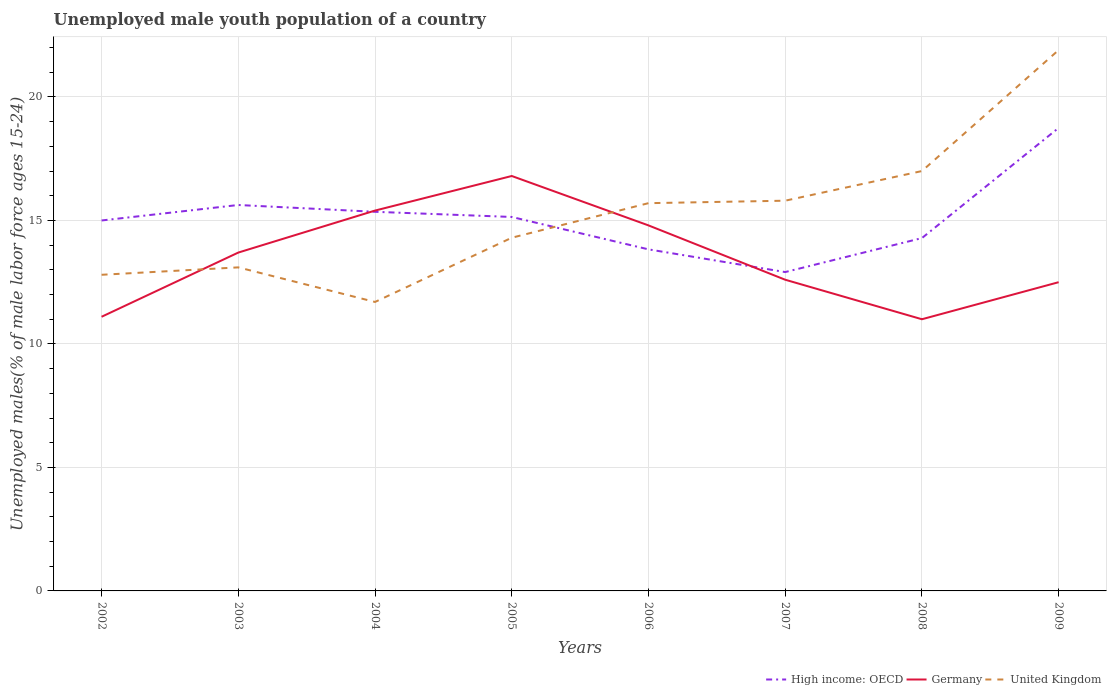Does the line corresponding to United Kingdom intersect with the line corresponding to Germany?
Keep it short and to the point. Yes. Across all years, what is the maximum percentage of unemployed male youth population in Germany?
Provide a succinct answer. 11. In which year was the percentage of unemployed male youth population in High income: OECD maximum?
Provide a short and direct response. 2007. What is the total percentage of unemployed male youth population in Germany in the graph?
Keep it short and to the point. 5.8. What is the difference between the highest and the second highest percentage of unemployed male youth population in Germany?
Ensure brevity in your answer.  5.8. Is the percentage of unemployed male youth population in Germany strictly greater than the percentage of unemployed male youth population in High income: OECD over the years?
Ensure brevity in your answer.  No. Are the values on the major ticks of Y-axis written in scientific E-notation?
Your answer should be compact. No. Does the graph contain any zero values?
Offer a very short reply. No. Where does the legend appear in the graph?
Provide a succinct answer. Bottom right. How many legend labels are there?
Provide a succinct answer. 3. What is the title of the graph?
Keep it short and to the point. Unemployed male youth population of a country. Does "Sweden" appear as one of the legend labels in the graph?
Offer a very short reply. No. What is the label or title of the Y-axis?
Give a very brief answer. Unemployed males(% of male labor force ages 15-24). What is the Unemployed males(% of male labor force ages 15-24) in High income: OECD in 2002?
Make the answer very short. 15. What is the Unemployed males(% of male labor force ages 15-24) of Germany in 2002?
Make the answer very short. 11.1. What is the Unemployed males(% of male labor force ages 15-24) in United Kingdom in 2002?
Your answer should be very brief. 12.8. What is the Unemployed males(% of male labor force ages 15-24) of High income: OECD in 2003?
Keep it short and to the point. 15.63. What is the Unemployed males(% of male labor force ages 15-24) of Germany in 2003?
Keep it short and to the point. 13.7. What is the Unemployed males(% of male labor force ages 15-24) of United Kingdom in 2003?
Provide a short and direct response. 13.1. What is the Unemployed males(% of male labor force ages 15-24) in High income: OECD in 2004?
Offer a very short reply. 15.35. What is the Unemployed males(% of male labor force ages 15-24) in Germany in 2004?
Your response must be concise. 15.4. What is the Unemployed males(% of male labor force ages 15-24) in United Kingdom in 2004?
Keep it short and to the point. 11.7. What is the Unemployed males(% of male labor force ages 15-24) in High income: OECD in 2005?
Your answer should be compact. 15.14. What is the Unemployed males(% of male labor force ages 15-24) of Germany in 2005?
Your answer should be very brief. 16.8. What is the Unemployed males(% of male labor force ages 15-24) of United Kingdom in 2005?
Your response must be concise. 14.3. What is the Unemployed males(% of male labor force ages 15-24) in High income: OECD in 2006?
Offer a terse response. 13.83. What is the Unemployed males(% of male labor force ages 15-24) of Germany in 2006?
Offer a terse response. 14.8. What is the Unemployed males(% of male labor force ages 15-24) in United Kingdom in 2006?
Provide a succinct answer. 15.7. What is the Unemployed males(% of male labor force ages 15-24) of High income: OECD in 2007?
Offer a terse response. 12.91. What is the Unemployed males(% of male labor force ages 15-24) of Germany in 2007?
Your answer should be very brief. 12.6. What is the Unemployed males(% of male labor force ages 15-24) of United Kingdom in 2007?
Offer a terse response. 15.8. What is the Unemployed males(% of male labor force ages 15-24) of High income: OECD in 2008?
Offer a terse response. 14.29. What is the Unemployed males(% of male labor force ages 15-24) of Germany in 2008?
Your response must be concise. 11. What is the Unemployed males(% of male labor force ages 15-24) of United Kingdom in 2008?
Provide a succinct answer. 17. What is the Unemployed males(% of male labor force ages 15-24) in High income: OECD in 2009?
Your answer should be very brief. 18.75. What is the Unemployed males(% of male labor force ages 15-24) of United Kingdom in 2009?
Make the answer very short. 21.9. Across all years, what is the maximum Unemployed males(% of male labor force ages 15-24) in High income: OECD?
Give a very brief answer. 18.75. Across all years, what is the maximum Unemployed males(% of male labor force ages 15-24) of Germany?
Provide a succinct answer. 16.8. Across all years, what is the maximum Unemployed males(% of male labor force ages 15-24) in United Kingdom?
Your response must be concise. 21.9. Across all years, what is the minimum Unemployed males(% of male labor force ages 15-24) in High income: OECD?
Provide a short and direct response. 12.91. Across all years, what is the minimum Unemployed males(% of male labor force ages 15-24) in United Kingdom?
Your answer should be very brief. 11.7. What is the total Unemployed males(% of male labor force ages 15-24) of High income: OECD in the graph?
Ensure brevity in your answer.  120.89. What is the total Unemployed males(% of male labor force ages 15-24) in Germany in the graph?
Offer a very short reply. 107.9. What is the total Unemployed males(% of male labor force ages 15-24) of United Kingdom in the graph?
Offer a terse response. 122.3. What is the difference between the Unemployed males(% of male labor force ages 15-24) of High income: OECD in 2002 and that in 2003?
Your answer should be compact. -0.63. What is the difference between the Unemployed males(% of male labor force ages 15-24) in Germany in 2002 and that in 2003?
Give a very brief answer. -2.6. What is the difference between the Unemployed males(% of male labor force ages 15-24) of United Kingdom in 2002 and that in 2003?
Keep it short and to the point. -0.3. What is the difference between the Unemployed males(% of male labor force ages 15-24) in High income: OECD in 2002 and that in 2004?
Offer a terse response. -0.35. What is the difference between the Unemployed males(% of male labor force ages 15-24) of United Kingdom in 2002 and that in 2004?
Ensure brevity in your answer.  1.1. What is the difference between the Unemployed males(% of male labor force ages 15-24) of High income: OECD in 2002 and that in 2005?
Your response must be concise. -0.14. What is the difference between the Unemployed males(% of male labor force ages 15-24) in Germany in 2002 and that in 2005?
Give a very brief answer. -5.7. What is the difference between the Unemployed males(% of male labor force ages 15-24) in United Kingdom in 2002 and that in 2005?
Ensure brevity in your answer.  -1.5. What is the difference between the Unemployed males(% of male labor force ages 15-24) in High income: OECD in 2002 and that in 2006?
Your answer should be very brief. 1.17. What is the difference between the Unemployed males(% of male labor force ages 15-24) in Germany in 2002 and that in 2006?
Make the answer very short. -3.7. What is the difference between the Unemployed males(% of male labor force ages 15-24) in United Kingdom in 2002 and that in 2006?
Provide a succinct answer. -2.9. What is the difference between the Unemployed males(% of male labor force ages 15-24) of High income: OECD in 2002 and that in 2007?
Ensure brevity in your answer.  2.09. What is the difference between the Unemployed males(% of male labor force ages 15-24) in United Kingdom in 2002 and that in 2007?
Make the answer very short. -3. What is the difference between the Unemployed males(% of male labor force ages 15-24) in High income: OECD in 2002 and that in 2008?
Offer a very short reply. 0.71. What is the difference between the Unemployed males(% of male labor force ages 15-24) in Germany in 2002 and that in 2008?
Make the answer very short. 0.1. What is the difference between the Unemployed males(% of male labor force ages 15-24) of United Kingdom in 2002 and that in 2008?
Make the answer very short. -4.2. What is the difference between the Unemployed males(% of male labor force ages 15-24) of High income: OECD in 2002 and that in 2009?
Your answer should be very brief. -3.75. What is the difference between the Unemployed males(% of male labor force ages 15-24) in High income: OECD in 2003 and that in 2004?
Ensure brevity in your answer.  0.28. What is the difference between the Unemployed males(% of male labor force ages 15-24) in High income: OECD in 2003 and that in 2005?
Provide a short and direct response. 0.48. What is the difference between the Unemployed males(% of male labor force ages 15-24) of Germany in 2003 and that in 2005?
Your answer should be very brief. -3.1. What is the difference between the Unemployed males(% of male labor force ages 15-24) in High income: OECD in 2003 and that in 2006?
Provide a short and direct response. 1.8. What is the difference between the Unemployed males(% of male labor force ages 15-24) of United Kingdom in 2003 and that in 2006?
Make the answer very short. -2.6. What is the difference between the Unemployed males(% of male labor force ages 15-24) in High income: OECD in 2003 and that in 2007?
Offer a very short reply. 2.72. What is the difference between the Unemployed males(% of male labor force ages 15-24) in High income: OECD in 2003 and that in 2008?
Your answer should be compact. 1.34. What is the difference between the Unemployed males(% of male labor force ages 15-24) in Germany in 2003 and that in 2008?
Give a very brief answer. 2.7. What is the difference between the Unemployed males(% of male labor force ages 15-24) in High income: OECD in 2003 and that in 2009?
Your response must be concise. -3.12. What is the difference between the Unemployed males(% of male labor force ages 15-24) of Germany in 2003 and that in 2009?
Your response must be concise. 1.2. What is the difference between the Unemployed males(% of male labor force ages 15-24) of United Kingdom in 2003 and that in 2009?
Ensure brevity in your answer.  -8.8. What is the difference between the Unemployed males(% of male labor force ages 15-24) in High income: OECD in 2004 and that in 2005?
Keep it short and to the point. 0.21. What is the difference between the Unemployed males(% of male labor force ages 15-24) of United Kingdom in 2004 and that in 2005?
Make the answer very short. -2.6. What is the difference between the Unemployed males(% of male labor force ages 15-24) of High income: OECD in 2004 and that in 2006?
Your answer should be compact. 1.52. What is the difference between the Unemployed males(% of male labor force ages 15-24) in Germany in 2004 and that in 2006?
Provide a short and direct response. 0.6. What is the difference between the Unemployed males(% of male labor force ages 15-24) of United Kingdom in 2004 and that in 2006?
Give a very brief answer. -4. What is the difference between the Unemployed males(% of male labor force ages 15-24) of High income: OECD in 2004 and that in 2007?
Your response must be concise. 2.44. What is the difference between the Unemployed males(% of male labor force ages 15-24) in Germany in 2004 and that in 2007?
Offer a very short reply. 2.8. What is the difference between the Unemployed males(% of male labor force ages 15-24) of High income: OECD in 2004 and that in 2008?
Ensure brevity in your answer.  1.06. What is the difference between the Unemployed males(% of male labor force ages 15-24) in Germany in 2004 and that in 2008?
Give a very brief answer. 4.4. What is the difference between the Unemployed males(% of male labor force ages 15-24) in United Kingdom in 2004 and that in 2008?
Give a very brief answer. -5.3. What is the difference between the Unemployed males(% of male labor force ages 15-24) in High income: OECD in 2004 and that in 2009?
Offer a very short reply. -3.4. What is the difference between the Unemployed males(% of male labor force ages 15-24) in United Kingdom in 2004 and that in 2009?
Provide a succinct answer. -10.2. What is the difference between the Unemployed males(% of male labor force ages 15-24) of High income: OECD in 2005 and that in 2006?
Offer a terse response. 1.31. What is the difference between the Unemployed males(% of male labor force ages 15-24) in United Kingdom in 2005 and that in 2006?
Your answer should be compact. -1.4. What is the difference between the Unemployed males(% of male labor force ages 15-24) in High income: OECD in 2005 and that in 2007?
Offer a terse response. 2.23. What is the difference between the Unemployed males(% of male labor force ages 15-24) of United Kingdom in 2005 and that in 2007?
Your answer should be compact. -1.5. What is the difference between the Unemployed males(% of male labor force ages 15-24) in High income: OECD in 2005 and that in 2008?
Ensure brevity in your answer.  0.86. What is the difference between the Unemployed males(% of male labor force ages 15-24) in United Kingdom in 2005 and that in 2008?
Give a very brief answer. -2.7. What is the difference between the Unemployed males(% of male labor force ages 15-24) of High income: OECD in 2005 and that in 2009?
Ensure brevity in your answer.  -3.61. What is the difference between the Unemployed males(% of male labor force ages 15-24) in Germany in 2005 and that in 2009?
Offer a very short reply. 4.3. What is the difference between the Unemployed males(% of male labor force ages 15-24) in United Kingdom in 2005 and that in 2009?
Ensure brevity in your answer.  -7.6. What is the difference between the Unemployed males(% of male labor force ages 15-24) of High income: OECD in 2006 and that in 2007?
Offer a very short reply. 0.92. What is the difference between the Unemployed males(% of male labor force ages 15-24) of Germany in 2006 and that in 2007?
Your answer should be very brief. 2.2. What is the difference between the Unemployed males(% of male labor force ages 15-24) in United Kingdom in 2006 and that in 2007?
Your answer should be very brief. -0.1. What is the difference between the Unemployed males(% of male labor force ages 15-24) in High income: OECD in 2006 and that in 2008?
Your response must be concise. -0.46. What is the difference between the Unemployed males(% of male labor force ages 15-24) of Germany in 2006 and that in 2008?
Your answer should be very brief. 3.8. What is the difference between the Unemployed males(% of male labor force ages 15-24) of United Kingdom in 2006 and that in 2008?
Offer a very short reply. -1.3. What is the difference between the Unemployed males(% of male labor force ages 15-24) of High income: OECD in 2006 and that in 2009?
Give a very brief answer. -4.92. What is the difference between the Unemployed males(% of male labor force ages 15-24) in High income: OECD in 2007 and that in 2008?
Ensure brevity in your answer.  -1.38. What is the difference between the Unemployed males(% of male labor force ages 15-24) of High income: OECD in 2007 and that in 2009?
Provide a short and direct response. -5.84. What is the difference between the Unemployed males(% of male labor force ages 15-24) of Germany in 2007 and that in 2009?
Keep it short and to the point. 0.1. What is the difference between the Unemployed males(% of male labor force ages 15-24) of High income: OECD in 2008 and that in 2009?
Your response must be concise. -4.46. What is the difference between the Unemployed males(% of male labor force ages 15-24) in United Kingdom in 2008 and that in 2009?
Keep it short and to the point. -4.9. What is the difference between the Unemployed males(% of male labor force ages 15-24) of High income: OECD in 2002 and the Unemployed males(% of male labor force ages 15-24) of Germany in 2003?
Provide a short and direct response. 1.3. What is the difference between the Unemployed males(% of male labor force ages 15-24) in High income: OECD in 2002 and the Unemployed males(% of male labor force ages 15-24) in United Kingdom in 2003?
Ensure brevity in your answer.  1.9. What is the difference between the Unemployed males(% of male labor force ages 15-24) of Germany in 2002 and the Unemployed males(% of male labor force ages 15-24) of United Kingdom in 2003?
Keep it short and to the point. -2. What is the difference between the Unemployed males(% of male labor force ages 15-24) of High income: OECD in 2002 and the Unemployed males(% of male labor force ages 15-24) of Germany in 2004?
Ensure brevity in your answer.  -0.4. What is the difference between the Unemployed males(% of male labor force ages 15-24) in High income: OECD in 2002 and the Unemployed males(% of male labor force ages 15-24) in United Kingdom in 2004?
Provide a short and direct response. 3.3. What is the difference between the Unemployed males(% of male labor force ages 15-24) in High income: OECD in 2002 and the Unemployed males(% of male labor force ages 15-24) in Germany in 2005?
Ensure brevity in your answer.  -1.8. What is the difference between the Unemployed males(% of male labor force ages 15-24) in High income: OECD in 2002 and the Unemployed males(% of male labor force ages 15-24) in United Kingdom in 2005?
Provide a short and direct response. 0.7. What is the difference between the Unemployed males(% of male labor force ages 15-24) in High income: OECD in 2002 and the Unemployed males(% of male labor force ages 15-24) in Germany in 2006?
Offer a terse response. 0.2. What is the difference between the Unemployed males(% of male labor force ages 15-24) of High income: OECD in 2002 and the Unemployed males(% of male labor force ages 15-24) of United Kingdom in 2006?
Provide a succinct answer. -0.7. What is the difference between the Unemployed males(% of male labor force ages 15-24) in High income: OECD in 2002 and the Unemployed males(% of male labor force ages 15-24) in Germany in 2007?
Your answer should be very brief. 2.4. What is the difference between the Unemployed males(% of male labor force ages 15-24) in High income: OECD in 2002 and the Unemployed males(% of male labor force ages 15-24) in United Kingdom in 2007?
Ensure brevity in your answer.  -0.8. What is the difference between the Unemployed males(% of male labor force ages 15-24) in Germany in 2002 and the Unemployed males(% of male labor force ages 15-24) in United Kingdom in 2007?
Provide a short and direct response. -4.7. What is the difference between the Unemployed males(% of male labor force ages 15-24) of High income: OECD in 2002 and the Unemployed males(% of male labor force ages 15-24) of Germany in 2008?
Make the answer very short. 4. What is the difference between the Unemployed males(% of male labor force ages 15-24) in High income: OECD in 2002 and the Unemployed males(% of male labor force ages 15-24) in United Kingdom in 2008?
Offer a terse response. -2. What is the difference between the Unemployed males(% of male labor force ages 15-24) in Germany in 2002 and the Unemployed males(% of male labor force ages 15-24) in United Kingdom in 2008?
Keep it short and to the point. -5.9. What is the difference between the Unemployed males(% of male labor force ages 15-24) in High income: OECD in 2002 and the Unemployed males(% of male labor force ages 15-24) in Germany in 2009?
Offer a terse response. 2.5. What is the difference between the Unemployed males(% of male labor force ages 15-24) in High income: OECD in 2002 and the Unemployed males(% of male labor force ages 15-24) in United Kingdom in 2009?
Your response must be concise. -6.9. What is the difference between the Unemployed males(% of male labor force ages 15-24) in Germany in 2002 and the Unemployed males(% of male labor force ages 15-24) in United Kingdom in 2009?
Your answer should be compact. -10.8. What is the difference between the Unemployed males(% of male labor force ages 15-24) in High income: OECD in 2003 and the Unemployed males(% of male labor force ages 15-24) in Germany in 2004?
Provide a short and direct response. 0.23. What is the difference between the Unemployed males(% of male labor force ages 15-24) of High income: OECD in 2003 and the Unemployed males(% of male labor force ages 15-24) of United Kingdom in 2004?
Your answer should be compact. 3.93. What is the difference between the Unemployed males(% of male labor force ages 15-24) in High income: OECD in 2003 and the Unemployed males(% of male labor force ages 15-24) in Germany in 2005?
Give a very brief answer. -1.17. What is the difference between the Unemployed males(% of male labor force ages 15-24) of High income: OECD in 2003 and the Unemployed males(% of male labor force ages 15-24) of United Kingdom in 2005?
Offer a very short reply. 1.33. What is the difference between the Unemployed males(% of male labor force ages 15-24) of High income: OECD in 2003 and the Unemployed males(% of male labor force ages 15-24) of Germany in 2006?
Provide a short and direct response. 0.83. What is the difference between the Unemployed males(% of male labor force ages 15-24) of High income: OECD in 2003 and the Unemployed males(% of male labor force ages 15-24) of United Kingdom in 2006?
Make the answer very short. -0.07. What is the difference between the Unemployed males(% of male labor force ages 15-24) in Germany in 2003 and the Unemployed males(% of male labor force ages 15-24) in United Kingdom in 2006?
Provide a short and direct response. -2. What is the difference between the Unemployed males(% of male labor force ages 15-24) of High income: OECD in 2003 and the Unemployed males(% of male labor force ages 15-24) of Germany in 2007?
Offer a terse response. 3.03. What is the difference between the Unemployed males(% of male labor force ages 15-24) of High income: OECD in 2003 and the Unemployed males(% of male labor force ages 15-24) of United Kingdom in 2007?
Your answer should be compact. -0.17. What is the difference between the Unemployed males(% of male labor force ages 15-24) in High income: OECD in 2003 and the Unemployed males(% of male labor force ages 15-24) in Germany in 2008?
Provide a short and direct response. 4.63. What is the difference between the Unemployed males(% of male labor force ages 15-24) of High income: OECD in 2003 and the Unemployed males(% of male labor force ages 15-24) of United Kingdom in 2008?
Your answer should be compact. -1.37. What is the difference between the Unemployed males(% of male labor force ages 15-24) in High income: OECD in 2003 and the Unemployed males(% of male labor force ages 15-24) in Germany in 2009?
Provide a short and direct response. 3.13. What is the difference between the Unemployed males(% of male labor force ages 15-24) in High income: OECD in 2003 and the Unemployed males(% of male labor force ages 15-24) in United Kingdom in 2009?
Provide a short and direct response. -6.27. What is the difference between the Unemployed males(% of male labor force ages 15-24) in Germany in 2003 and the Unemployed males(% of male labor force ages 15-24) in United Kingdom in 2009?
Provide a short and direct response. -8.2. What is the difference between the Unemployed males(% of male labor force ages 15-24) in High income: OECD in 2004 and the Unemployed males(% of male labor force ages 15-24) in Germany in 2005?
Your answer should be very brief. -1.45. What is the difference between the Unemployed males(% of male labor force ages 15-24) in High income: OECD in 2004 and the Unemployed males(% of male labor force ages 15-24) in United Kingdom in 2005?
Give a very brief answer. 1.05. What is the difference between the Unemployed males(% of male labor force ages 15-24) in High income: OECD in 2004 and the Unemployed males(% of male labor force ages 15-24) in Germany in 2006?
Ensure brevity in your answer.  0.55. What is the difference between the Unemployed males(% of male labor force ages 15-24) in High income: OECD in 2004 and the Unemployed males(% of male labor force ages 15-24) in United Kingdom in 2006?
Your answer should be very brief. -0.35. What is the difference between the Unemployed males(% of male labor force ages 15-24) of High income: OECD in 2004 and the Unemployed males(% of male labor force ages 15-24) of Germany in 2007?
Provide a succinct answer. 2.75. What is the difference between the Unemployed males(% of male labor force ages 15-24) in High income: OECD in 2004 and the Unemployed males(% of male labor force ages 15-24) in United Kingdom in 2007?
Ensure brevity in your answer.  -0.45. What is the difference between the Unemployed males(% of male labor force ages 15-24) in High income: OECD in 2004 and the Unemployed males(% of male labor force ages 15-24) in Germany in 2008?
Offer a terse response. 4.35. What is the difference between the Unemployed males(% of male labor force ages 15-24) of High income: OECD in 2004 and the Unemployed males(% of male labor force ages 15-24) of United Kingdom in 2008?
Offer a terse response. -1.65. What is the difference between the Unemployed males(% of male labor force ages 15-24) in High income: OECD in 2004 and the Unemployed males(% of male labor force ages 15-24) in Germany in 2009?
Offer a very short reply. 2.85. What is the difference between the Unemployed males(% of male labor force ages 15-24) of High income: OECD in 2004 and the Unemployed males(% of male labor force ages 15-24) of United Kingdom in 2009?
Your answer should be compact. -6.55. What is the difference between the Unemployed males(% of male labor force ages 15-24) of Germany in 2004 and the Unemployed males(% of male labor force ages 15-24) of United Kingdom in 2009?
Offer a very short reply. -6.5. What is the difference between the Unemployed males(% of male labor force ages 15-24) in High income: OECD in 2005 and the Unemployed males(% of male labor force ages 15-24) in Germany in 2006?
Offer a terse response. 0.34. What is the difference between the Unemployed males(% of male labor force ages 15-24) of High income: OECD in 2005 and the Unemployed males(% of male labor force ages 15-24) of United Kingdom in 2006?
Your response must be concise. -0.56. What is the difference between the Unemployed males(% of male labor force ages 15-24) of Germany in 2005 and the Unemployed males(% of male labor force ages 15-24) of United Kingdom in 2006?
Provide a succinct answer. 1.1. What is the difference between the Unemployed males(% of male labor force ages 15-24) of High income: OECD in 2005 and the Unemployed males(% of male labor force ages 15-24) of Germany in 2007?
Offer a terse response. 2.54. What is the difference between the Unemployed males(% of male labor force ages 15-24) of High income: OECD in 2005 and the Unemployed males(% of male labor force ages 15-24) of United Kingdom in 2007?
Your answer should be compact. -0.66. What is the difference between the Unemployed males(% of male labor force ages 15-24) of High income: OECD in 2005 and the Unemployed males(% of male labor force ages 15-24) of Germany in 2008?
Offer a very short reply. 4.14. What is the difference between the Unemployed males(% of male labor force ages 15-24) of High income: OECD in 2005 and the Unemployed males(% of male labor force ages 15-24) of United Kingdom in 2008?
Ensure brevity in your answer.  -1.86. What is the difference between the Unemployed males(% of male labor force ages 15-24) in Germany in 2005 and the Unemployed males(% of male labor force ages 15-24) in United Kingdom in 2008?
Offer a very short reply. -0.2. What is the difference between the Unemployed males(% of male labor force ages 15-24) in High income: OECD in 2005 and the Unemployed males(% of male labor force ages 15-24) in Germany in 2009?
Offer a very short reply. 2.64. What is the difference between the Unemployed males(% of male labor force ages 15-24) of High income: OECD in 2005 and the Unemployed males(% of male labor force ages 15-24) of United Kingdom in 2009?
Offer a very short reply. -6.76. What is the difference between the Unemployed males(% of male labor force ages 15-24) in High income: OECD in 2006 and the Unemployed males(% of male labor force ages 15-24) in Germany in 2007?
Your answer should be compact. 1.23. What is the difference between the Unemployed males(% of male labor force ages 15-24) of High income: OECD in 2006 and the Unemployed males(% of male labor force ages 15-24) of United Kingdom in 2007?
Make the answer very short. -1.97. What is the difference between the Unemployed males(% of male labor force ages 15-24) in Germany in 2006 and the Unemployed males(% of male labor force ages 15-24) in United Kingdom in 2007?
Make the answer very short. -1. What is the difference between the Unemployed males(% of male labor force ages 15-24) of High income: OECD in 2006 and the Unemployed males(% of male labor force ages 15-24) of Germany in 2008?
Ensure brevity in your answer.  2.83. What is the difference between the Unemployed males(% of male labor force ages 15-24) in High income: OECD in 2006 and the Unemployed males(% of male labor force ages 15-24) in United Kingdom in 2008?
Your answer should be very brief. -3.17. What is the difference between the Unemployed males(% of male labor force ages 15-24) of Germany in 2006 and the Unemployed males(% of male labor force ages 15-24) of United Kingdom in 2008?
Provide a short and direct response. -2.2. What is the difference between the Unemployed males(% of male labor force ages 15-24) in High income: OECD in 2006 and the Unemployed males(% of male labor force ages 15-24) in Germany in 2009?
Make the answer very short. 1.33. What is the difference between the Unemployed males(% of male labor force ages 15-24) in High income: OECD in 2006 and the Unemployed males(% of male labor force ages 15-24) in United Kingdom in 2009?
Offer a very short reply. -8.07. What is the difference between the Unemployed males(% of male labor force ages 15-24) of High income: OECD in 2007 and the Unemployed males(% of male labor force ages 15-24) of Germany in 2008?
Give a very brief answer. 1.91. What is the difference between the Unemployed males(% of male labor force ages 15-24) in High income: OECD in 2007 and the Unemployed males(% of male labor force ages 15-24) in United Kingdom in 2008?
Offer a very short reply. -4.09. What is the difference between the Unemployed males(% of male labor force ages 15-24) of Germany in 2007 and the Unemployed males(% of male labor force ages 15-24) of United Kingdom in 2008?
Make the answer very short. -4.4. What is the difference between the Unemployed males(% of male labor force ages 15-24) in High income: OECD in 2007 and the Unemployed males(% of male labor force ages 15-24) in Germany in 2009?
Your answer should be compact. 0.41. What is the difference between the Unemployed males(% of male labor force ages 15-24) of High income: OECD in 2007 and the Unemployed males(% of male labor force ages 15-24) of United Kingdom in 2009?
Offer a terse response. -8.99. What is the difference between the Unemployed males(% of male labor force ages 15-24) of Germany in 2007 and the Unemployed males(% of male labor force ages 15-24) of United Kingdom in 2009?
Make the answer very short. -9.3. What is the difference between the Unemployed males(% of male labor force ages 15-24) of High income: OECD in 2008 and the Unemployed males(% of male labor force ages 15-24) of Germany in 2009?
Provide a succinct answer. 1.79. What is the difference between the Unemployed males(% of male labor force ages 15-24) in High income: OECD in 2008 and the Unemployed males(% of male labor force ages 15-24) in United Kingdom in 2009?
Provide a succinct answer. -7.61. What is the average Unemployed males(% of male labor force ages 15-24) of High income: OECD per year?
Provide a succinct answer. 15.11. What is the average Unemployed males(% of male labor force ages 15-24) of Germany per year?
Offer a terse response. 13.49. What is the average Unemployed males(% of male labor force ages 15-24) of United Kingdom per year?
Provide a short and direct response. 15.29. In the year 2002, what is the difference between the Unemployed males(% of male labor force ages 15-24) in High income: OECD and Unemployed males(% of male labor force ages 15-24) in Germany?
Keep it short and to the point. 3.9. In the year 2002, what is the difference between the Unemployed males(% of male labor force ages 15-24) of High income: OECD and Unemployed males(% of male labor force ages 15-24) of United Kingdom?
Offer a very short reply. 2.2. In the year 2003, what is the difference between the Unemployed males(% of male labor force ages 15-24) of High income: OECD and Unemployed males(% of male labor force ages 15-24) of Germany?
Your response must be concise. 1.93. In the year 2003, what is the difference between the Unemployed males(% of male labor force ages 15-24) in High income: OECD and Unemployed males(% of male labor force ages 15-24) in United Kingdom?
Your response must be concise. 2.53. In the year 2003, what is the difference between the Unemployed males(% of male labor force ages 15-24) of Germany and Unemployed males(% of male labor force ages 15-24) of United Kingdom?
Your answer should be very brief. 0.6. In the year 2004, what is the difference between the Unemployed males(% of male labor force ages 15-24) of High income: OECD and Unemployed males(% of male labor force ages 15-24) of Germany?
Offer a terse response. -0.05. In the year 2004, what is the difference between the Unemployed males(% of male labor force ages 15-24) of High income: OECD and Unemployed males(% of male labor force ages 15-24) of United Kingdom?
Your response must be concise. 3.65. In the year 2004, what is the difference between the Unemployed males(% of male labor force ages 15-24) of Germany and Unemployed males(% of male labor force ages 15-24) of United Kingdom?
Make the answer very short. 3.7. In the year 2005, what is the difference between the Unemployed males(% of male labor force ages 15-24) of High income: OECD and Unemployed males(% of male labor force ages 15-24) of Germany?
Offer a terse response. -1.66. In the year 2005, what is the difference between the Unemployed males(% of male labor force ages 15-24) in High income: OECD and Unemployed males(% of male labor force ages 15-24) in United Kingdom?
Your answer should be very brief. 0.84. In the year 2006, what is the difference between the Unemployed males(% of male labor force ages 15-24) in High income: OECD and Unemployed males(% of male labor force ages 15-24) in Germany?
Provide a short and direct response. -0.97. In the year 2006, what is the difference between the Unemployed males(% of male labor force ages 15-24) of High income: OECD and Unemployed males(% of male labor force ages 15-24) of United Kingdom?
Keep it short and to the point. -1.87. In the year 2006, what is the difference between the Unemployed males(% of male labor force ages 15-24) of Germany and Unemployed males(% of male labor force ages 15-24) of United Kingdom?
Provide a succinct answer. -0.9. In the year 2007, what is the difference between the Unemployed males(% of male labor force ages 15-24) of High income: OECD and Unemployed males(% of male labor force ages 15-24) of Germany?
Offer a very short reply. 0.31. In the year 2007, what is the difference between the Unemployed males(% of male labor force ages 15-24) of High income: OECD and Unemployed males(% of male labor force ages 15-24) of United Kingdom?
Provide a short and direct response. -2.89. In the year 2007, what is the difference between the Unemployed males(% of male labor force ages 15-24) of Germany and Unemployed males(% of male labor force ages 15-24) of United Kingdom?
Make the answer very short. -3.2. In the year 2008, what is the difference between the Unemployed males(% of male labor force ages 15-24) in High income: OECD and Unemployed males(% of male labor force ages 15-24) in Germany?
Ensure brevity in your answer.  3.29. In the year 2008, what is the difference between the Unemployed males(% of male labor force ages 15-24) of High income: OECD and Unemployed males(% of male labor force ages 15-24) of United Kingdom?
Ensure brevity in your answer.  -2.71. In the year 2009, what is the difference between the Unemployed males(% of male labor force ages 15-24) of High income: OECD and Unemployed males(% of male labor force ages 15-24) of Germany?
Your answer should be very brief. 6.25. In the year 2009, what is the difference between the Unemployed males(% of male labor force ages 15-24) of High income: OECD and Unemployed males(% of male labor force ages 15-24) of United Kingdom?
Provide a succinct answer. -3.15. In the year 2009, what is the difference between the Unemployed males(% of male labor force ages 15-24) in Germany and Unemployed males(% of male labor force ages 15-24) in United Kingdom?
Provide a succinct answer. -9.4. What is the ratio of the Unemployed males(% of male labor force ages 15-24) in High income: OECD in 2002 to that in 2003?
Offer a terse response. 0.96. What is the ratio of the Unemployed males(% of male labor force ages 15-24) in Germany in 2002 to that in 2003?
Keep it short and to the point. 0.81. What is the ratio of the Unemployed males(% of male labor force ages 15-24) of United Kingdom in 2002 to that in 2003?
Provide a short and direct response. 0.98. What is the ratio of the Unemployed males(% of male labor force ages 15-24) of High income: OECD in 2002 to that in 2004?
Your answer should be compact. 0.98. What is the ratio of the Unemployed males(% of male labor force ages 15-24) of Germany in 2002 to that in 2004?
Give a very brief answer. 0.72. What is the ratio of the Unemployed males(% of male labor force ages 15-24) of United Kingdom in 2002 to that in 2004?
Make the answer very short. 1.09. What is the ratio of the Unemployed males(% of male labor force ages 15-24) in High income: OECD in 2002 to that in 2005?
Offer a terse response. 0.99. What is the ratio of the Unemployed males(% of male labor force ages 15-24) in Germany in 2002 to that in 2005?
Keep it short and to the point. 0.66. What is the ratio of the Unemployed males(% of male labor force ages 15-24) of United Kingdom in 2002 to that in 2005?
Make the answer very short. 0.9. What is the ratio of the Unemployed males(% of male labor force ages 15-24) of High income: OECD in 2002 to that in 2006?
Your answer should be compact. 1.08. What is the ratio of the Unemployed males(% of male labor force ages 15-24) of United Kingdom in 2002 to that in 2006?
Offer a terse response. 0.82. What is the ratio of the Unemployed males(% of male labor force ages 15-24) of High income: OECD in 2002 to that in 2007?
Your answer should be compact. 1.16. What is the ratio of the Unemployed males(% of male labor force ages 15-24) in Germany in 2002 to that in 2007?
Provide a short and direct response. 0.88. What is the ratio of the Unemployed males(% of male labor force ages 15-24) of United Kingdom in 2002 to that in 2007?
Ensure brevity in your answer.  0.81. What is the ratio of the Unemployed males(% of male labor force ages 15-24) in High income: OECD in 2002 to that in 2008?
Provide a short and direct response. 1.05. What is the ratio of the Unemployed males(% of male labor force ages 15-24) in Germany in 2002 to that in 2008?
Keep it short and to the point. 1.01. What is the ratio of the Unemployed males(% of male labor force ages 15-24) in United Kingdom in 2002 to that in 2008?
Give a very brief answer. 0.75. What is the ratio of the Unemployed males(% of male labor force ages 15-24) in High income: OECD in 2002 to that in 2009?
Your answer should be compact. 0.8. What is the ratio of the Unemployed males(% of male labor force ages 15-24) of Germany in 2002 to that in 2009?
Offer a very short reply. 0.89. What is the ratio of the Unemployed males(% of male labor force ages 15-24) of United Kingdom in 2002 to that in 2009?
Provide a succinct answer. 0.58. What is the ratio of the Unemployed males(% of male labor force ages 15-24) of High income: OECD in 2003 to that in 2004?
Your response must be concise. 1.02. What is the ratio of the Unemployed males(% of male labor force ages 15-24) in Germany in 2003 to that in 2004?
Your response must be concise. 0.89. What is the ratio of the Unemployed males(% of male labor force ages 15-24) of United Kingdom in 2003 to that in 2004?
Ensure brevity in your answer.  1.12. What is the ratio of the Unemployed males(% of male labor force ages 15-24) of High income: OECD in 2003 to that in 2005?
Your answer should be compact. 1.03. What is the ratio of the Unemployed males(% of male labor force ages 15-24) of Germany in 2003 to that in 2005?
Your answer should be very brief. 0.82. What is the ratio of the Unemployed males(% of male labor force ages 15-24) in United Kingdom in 2003 to that in 2005?
Your answer should be compact. 0.92. What is the ratio of the Unemployed males(% of male labor force ages 15-24) of High income: OECD in 2003 to that in 2006?
Ensure brevity in your answer.  1.13. What is the ratio of the Unemployed males(% of male labor force ages 15-24) in Germany in 2003 to that in 2006?
Your answer should be very brief. 0.93. What is the ratio of the Unemployed males(% of male labor force ages 15-24) in United Kingdom in 2003 to that in 2006?
Give a very brief answer. 0.83. What is the ratio of the Unemployed males(% of male labor force ages 15-24) of High income: OECD in 2003 to that in 2007?
Ensure brevity in your answer.  1.21. What is the ratio of the Unemployed males(% of male labor force ages 15-24) of Germany in 2003 to that in 2007?
Offer a very short reply. 1.09. What is the ratio of the Unemployed males(% of male labor force ages 15-24) in United Kingdom in 2003 to that in 2007?
Offer a very short reply. 0.83. What is the ratio of the Unemployed males(% of male labor force ages 15-24) of High income: OECD in 2003 to that in 2008?
Your answer should be compact. 1.09. What is the ratio of the Unemployed males(% of male labor force ages 15-24) of Germany in 2003 to that in 2008?
Your answer should be very brief. 1.25. What is the ratio of the Unemployed males(% of male labor force ages 15-24) of United Kingdom in 2003 to that in 2008?
Give a very brief answer. 0.77. What is the ratio of the Unemployed males(% of male labor force ages 15-24) of High income: OECD in 2003 to that in 2009?
Your answer should be very brief. 0.83. What is the ratio of the Unemployed males(% of male labor force ages 15-24) in Germany in 2003 to that in 2009?
Ensure brevity in your answer.  1.1. What is the ratio of the Unemployed males(% of male labor force ages 15-24) in United Kingdom in 2003 to that in 2009?
Ensure brevity in your answer.  0.6. What is the ratio of the Unemployed males(% of male labor force ages 15-24) of High income: OECD in 2004 to that in 2005?
Give a very brief answer. 1.01. What is the ratio of the Unemployed males(% of male labor force ages 15-24) of Germany in 2004 to that in 2005?
Ensure brevity in your answer.  0.92. What is the ratio of the Unemployed males(% of male labor force ages 15-24) in United Kingdom in 2004 to that in 2005?
Offer a very short reply. 0.82. What is the ratio of the Unemployed males(% of male labor force ages 15-24) in High income: OECD in 2004 to that in 2006?
Your response must be concise. 1.11. What is the ratio of the Unemployed males(% of male labor force ages 15-24) in Germany in 2004 to that in 2006?
Offer a very short reply. 1.04. What is the ratio of the Unemployed males(% of male labor force ages 15-24) in United Kingdom in 2004 to that in 2006?
Offer a very short reply. 0.75. What is the ratio of the Unemployed males(% of male labor force ages 15-24) in High income: OECD in 2004 to that in 2007?
Offer a terse response. 1.19. What is the ratio of the Unemployed males(% of male labor force ages 15-24) in Germany in 2004 to that in 2007?
Offer a very short reply. 1.22. What is the ratio of the Unemployed males(% of male labor force ages 15-24) of United Kingdom in 2004 to that in 2007?
Your answer should be very brief. 0.74. What is the ratio of the Unemployed males(% of male labor force ages 15-24) of High income: OECD in 2004 to that in 2008?
Ensure brevity in your answer.  1.07. What is the ratio of the Unemployed males(% of male labor force ages 15-24) of United Kingdom in 2004 to that in 2008?
Ensure brevity in your answer.  0.69. What is the ratio of the Unemployed males(% of male labor force ages 15-24) in High income: OECD in 2004 to that in 2009?
Ensure brevity in your answer.  0.82. What is the ratio of the Unemployed males(% of male labor force ages 15-24) of Germany in 2004 to that in 2009?
Provide a short and direct response. 1.23. What is the ratio of the Unemployed males(% of male labor force ages 15-24) of United Kingdom in 2004 to that in 2009?
Your answer should be very brief. 0.53. What is the ratio of the Unemployed males(% of male labor force ages 15-24) of High income: OECD in 2005 to that in 2006?
Your answer should be very brief. 1.09. What is the ratio of the Unemployed males(% of male labor force ages 15-24) in Germany in 2005 to that in 2006?
Your answer should be compact. 1.14. What is the ratio of the Unemployed males(% of male labor force ages 15-24) of United Kingdom in 2005 to that in 2006?
Your answer should be very brief. 0.91. What is the ratio of the Unemployed males(% of male labor force ages 15-24) of High income: OECD in 2005 to that in 2007?
Make the answer very short. 1.17. What is the ratio of the Unemployed males(% of male labor force ages 15-24) of United Kingdom in 2005 to that in 2007?
Provide a short and direct response. 0.91. What is the ratio of the Unemployed males(% of male labor force ages 15-24) in High income: OECD in 2005 to that in 2008?
Offer a very short reply. 1.06. What is the ratio of the Unemployed males(% of male labor force ages 15-24) of Germany in 2005 to that in 2008?
Provide a short and direct response. 1.53. What is the ratio of the Unemployed males(% of male labor force ages 15-24) of United Kingdom in 2005 to that in 2008?
Make the answer very short. 0.84. What is the ratio of the Unemployed males(% of male labor force ages 15-24) in High income: OECD in 2005 to that in 2009?
Ensure brevity in your answer.  0.81. What is the ratio of the Unemployed males(% of male labor force ages 15-24) of Germany in 2005 to that in 2009?
Provide a short and direct response. 1.34. What is the ratio of the Unemployed males(% of male labor force ages 15-24) of United Kingdom in 2005 to that in 2009?
Your answer should be very brief. 0.65. What is the ratio of the Unemployed males(% of male labor force ages 15-24) in High income: OECD in 2006 to that in 2007?
Make the answer very short. 1.07. What is the ratio of the Unemployed males(% of male labor force ages 15-24) of Germany in 2006 to that in 2007?
Your answer should be very brief. 1.17. What is the ratio of the Unemployed males(% of male labor force ages 15-24) of United Kingdom in 2006 to that in 2007?
Ensure brevity in your answer.  0.99. What is the ratio of the Unemployed males(% of male labor force ages 15-24) of High income: OECD in 2006 to that in 2008?
Offer a terse response. 0.97. What is the ratio of the Unemployed males(% of male labor force ages 15-24) of Germany in 2006 to that in 2008?
Offer a terse response. 1.35. What is the ratio of the Unemployed males(% of male labor force ages 15-24) in United Kingdom in 2006 to that in 2008?
Provide a succinct answer. 0.92. What is the ratio of the Unemployed males(% of male labor force ages 15-24) of High income: OECD in 2006 to that in 2009?
Your answer should be very brief. 0.74. What is the ratio of the Unemployed males(% of male labor force ages 15-24) in Germany in 2006 to that in 2009?
Your response must be concise. 1.18. What is the ratio of the Unemployed males(% of male labor force ages 15-24) of United Kingdom in 2006 to that in 2009?
Offer a very short reply. 0.72. What is the ratio of the Unemployed males(% of male labor force ages 15-24) in High income: OECD in 2007 to that in 2008?
Provide a short and direct response. 0.9. What is the ratio of the Unemployed males(% of male labor force ages 15-24) in Germany in 2007 to that in 2008?
Keep it short and to the point. 1.15. What is the ratio of the Unemployed males(% of male labor force ages 15-24) of United Kingdom in 2007 to that in 2008?
Keep it short and to the point. 0.93. What is the ratio of the Unemployed males(% of male labor force ages 15-24) in High income: OECD in 2007 to that in 2009?
Provide a short and direct response. 0.69. What is the ratio of the Unemployed males(% of male labor force ages 15-24) in United Kingdom in 2007 to that in 2009?
Make the answer very short. 0.72. What is the ratio of the Unemployed males(% of male labor force ages 15-24) in High income: OECD in 2008 to that in 2009?
Give a very brief answer. 0.76. What is the ratio of the Unemployed males(% of male labor force ages 15-24) in Germany in 2008 to that in 2009?
Your response must be concise. 0.88. What is the ratio of the Unemployed males(% of male labor force ages 15-24) in United Kingdom in 2008 to that in 2009?
Your response must be concise. 0.78. What is the difference between the highest and the second highest Unemployed males(% of male labor force ages 15-24) of High income: OECD?
Give a very brief answer. 3.12. What is the difference between the highest and the second highest Unemployed males(% of male labor force ages 15-24) in United Kingdom?
Offer a very short reply. 4.9. What is the difference between the highest and the lowest Unemployed males(% of male labor force ages 15-24) in High income: OECD?
Your answer should be compact. 5.84. What is the difference between the highest and the lowest Unemployed males(% of male labor force ages 15-24) in Germany?
Make the answer very short. 5.8. 